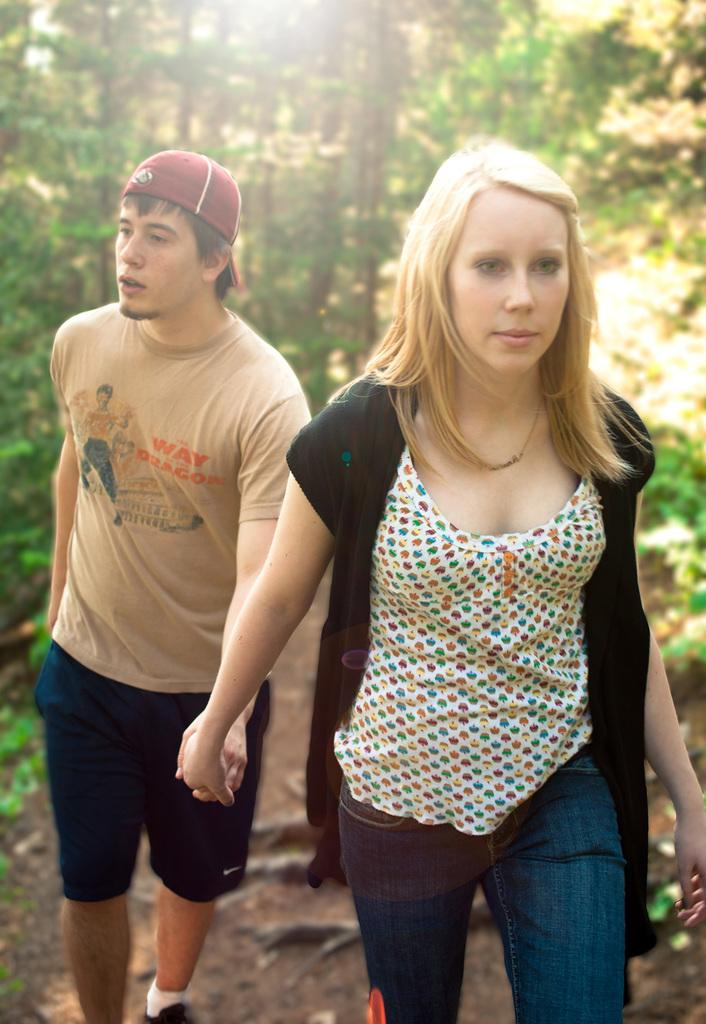Who can be seen in the foreground of the image? There is a man and a woman in the foreground of the image. What are the man and woman doing in the image? The man and woman are holding hands and walking. What can be seen in the background of the image? There are trees in the background of the image. What type of surface is visible at the bottom of the image? There is sand at the bottom of the image. Where is the market located in the image? There is no market present in the image. What type of treatment is the woman receiving in the image? There is no treatment being administered in the image; the man and woman are simply walking and holding hands. 